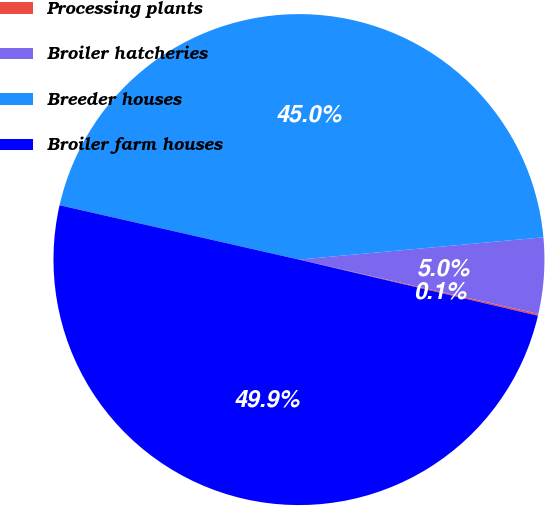Convert chart to OTSL. <chart><loc_0><loc_0><loc_500><loc_500><pie_chart><fcel>Processing plants<fcel>Broiler hatcheries<fcel>Breeder houses<fcel>Broiler farm houses<nl><fcel>0.12%<fcel>5.0%<fcel>45.0%<fcel>49.88%<nl></chart> 